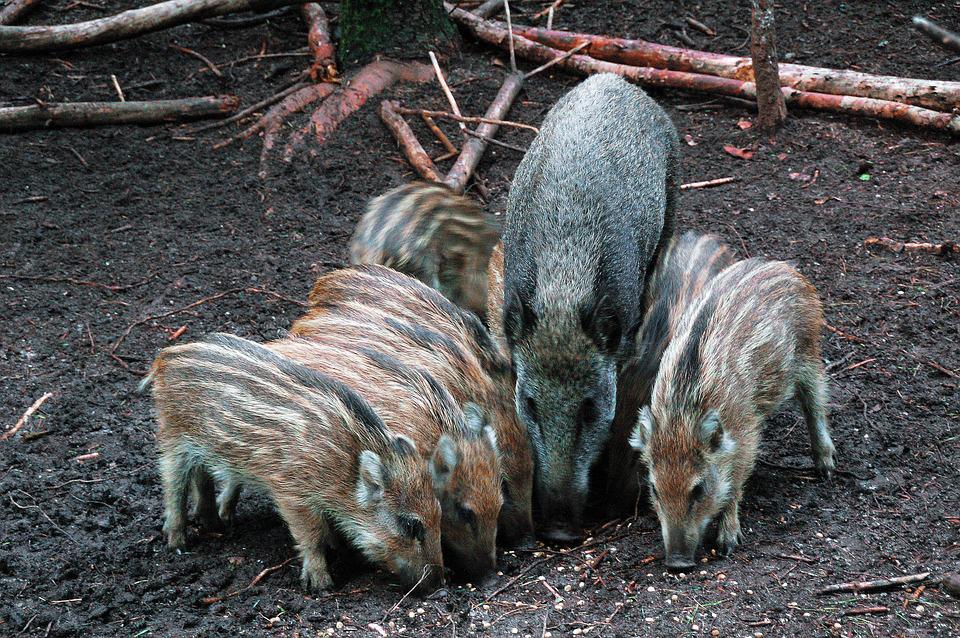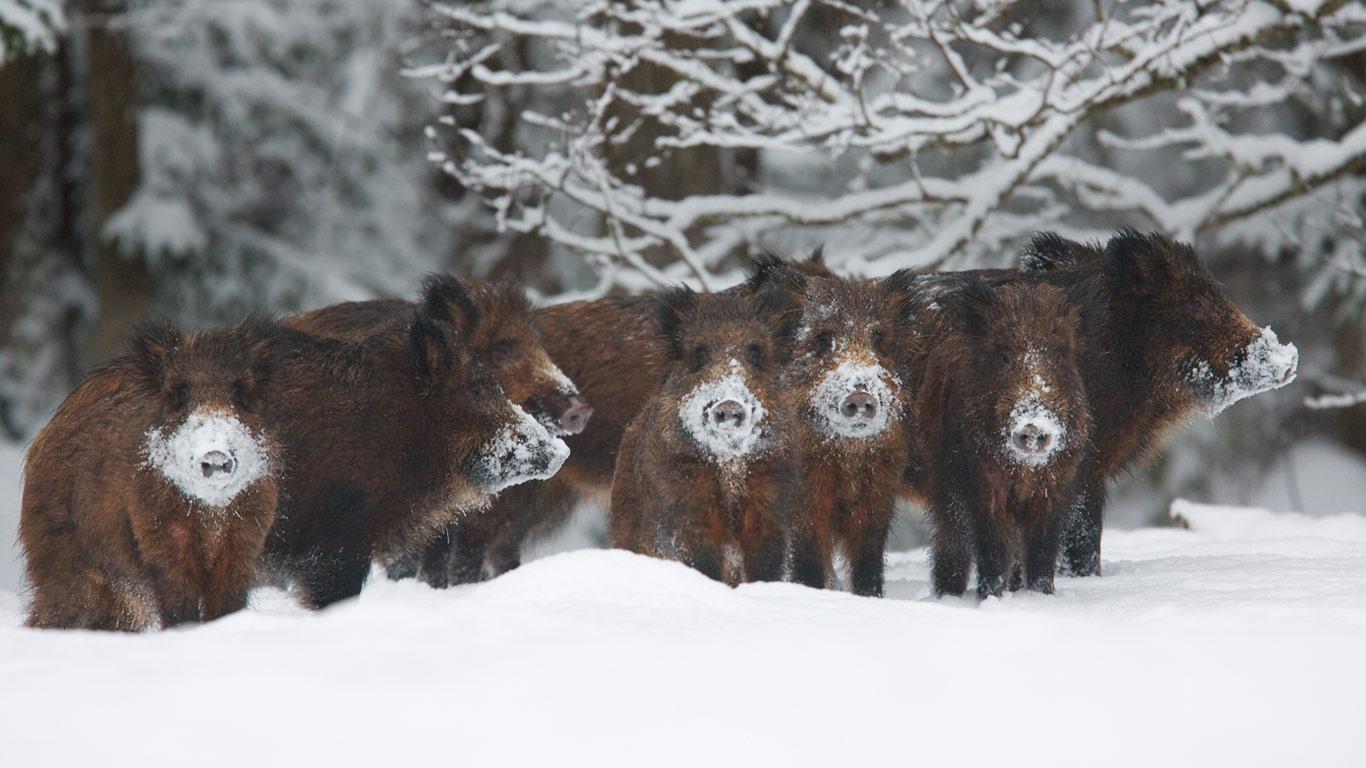The first image is the image on the left, the second image is the image on the right. Given the left and right images, does the statement "There are no more than 2 wild pigs." hold true? Answer yes or no. No. The first image is the image on the left, the second image is the image on the right. Evaluate the accuracy of this statement regarding the images: "there are two warthogs in the image pair". Is it true? Answer yes or no. No. 